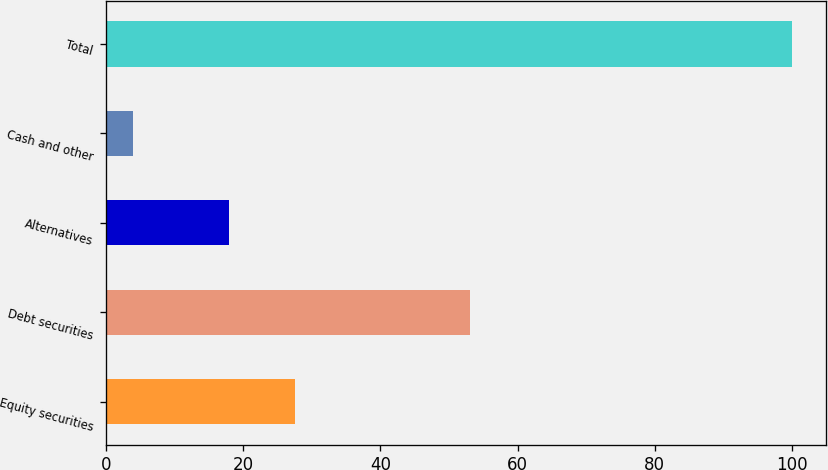Convert chart. <chart><loc_0><loc_0><loc_500><loc_500><bar_chart><fcel>Equity securities<fcel>Debt securities<fcel>Alternatives<fcel>Cash and other<fcel>Total<nl><fcel>27.6<fcel>53<fcel>18<fcel>4<fcel>100<nl></chart> 